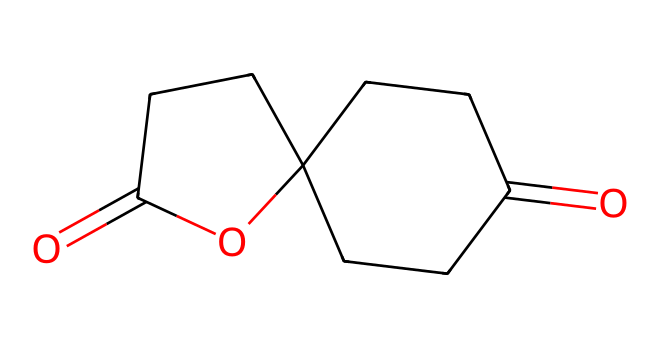What is the molecular formula of calone? From the SMILES representation, we can deduce the elements present and their counts: the compound includes carbon (C), hydrogen (H), and oxygen (O). By analyzing the structure, we find 12 carbon atoms, 18 hydrogen atoms, and 2 oxygen atoms, which gives us the molecular formula C12H18O2.
Answer: C12H18O2 How many rings are present in calone? By examining the structure, we can identify the cyclic portions of the molecule. There are two distinct rings present: one is a five-membered ring, and the other is a six-membered ring. Therefore, there are a total of two rings in the molecular structure.
Answer: 2 What type of compound is calone classified as? The structure of calone features a cage-like arrangement of atoms that is characteristic of cage compounds. It consists of a bicyclic framework, which indicates that it belongs to the category of cage compounds specifically.
Answer: cage compound What are the total number of double bonds in calone? Looking at the structure, we can locate the double bonds: there are two carbonyl (C=O) double bonds present in the structure of calone. Other types of double bonds are not observed in the representation. Thus, the total number of double bonds is two.
Answer: 2 What functional groups are present in calone? Analyzing the structure, we recognize the presence of carbonyl (C=O) groups as well as an ester functional group derived from the cyclic structure and the carbonyls. These components dictate the functional characteristics of the compound.
Answer: carbonyl and ester 